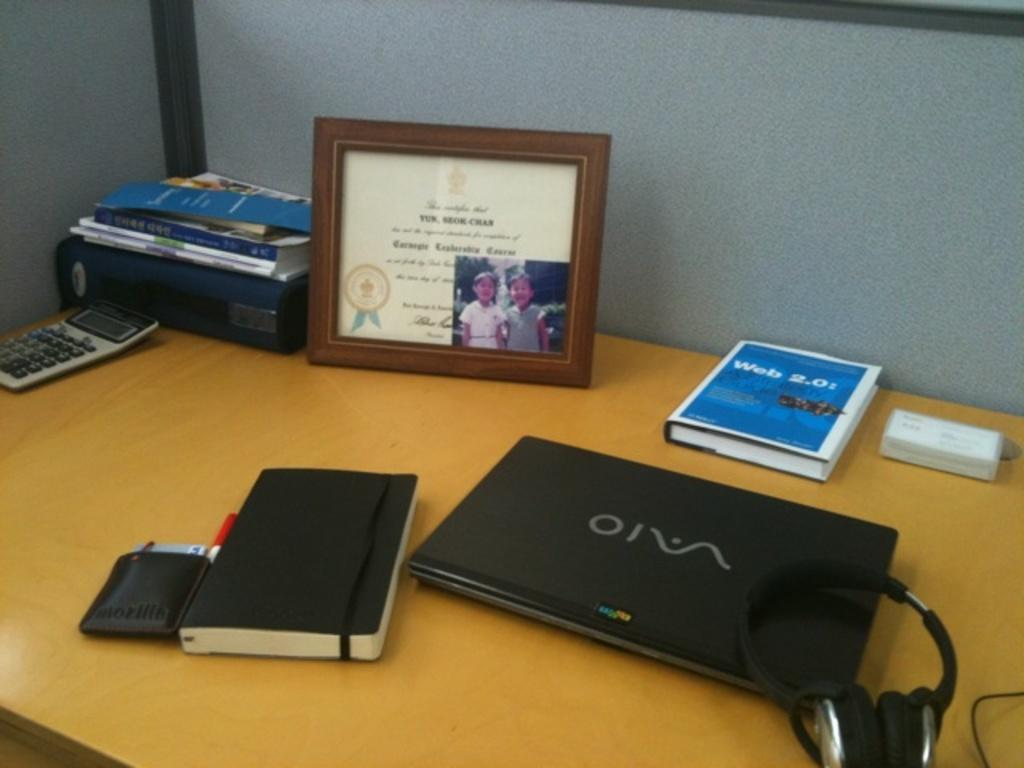<image>
Summarize the visual content of the image. A book titled Web 2.0 next to a laptop on a desk. 